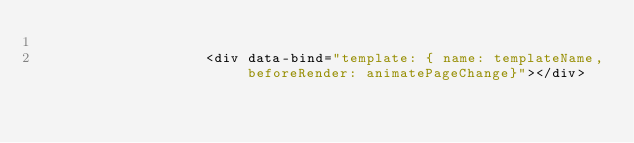<code> <loc_0><loc_0><loc_500><loc_500><_HTML_>
					<div data-bind="template: { name: templateName, beforeRender: animatePageChange}"></div>
					
					
				</code> 